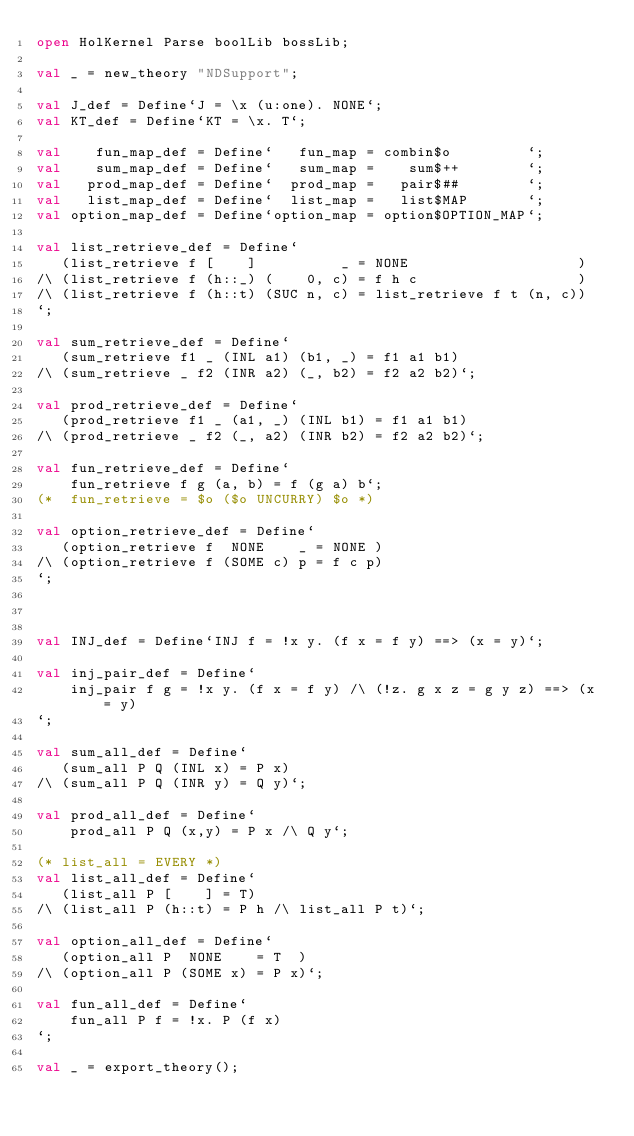Convert code to text. <code><loc_0><loc_0><loc_500><loc_500><_SML_>open HolKernel Parse boolLib bossLib;

val _ = new_theory "NDSupport";

val J_def = Define`J = \x (u:one). NONE`;
val KT_def = Define`KT = \x. T`;

val    fun_map_def = Define`   fun_map = combin$o         `;
val    sum_map_def = Define`   sum_map =    sum$++        `;
val   prod_map_def = Define`  prod_map =   pair$##        `;
val   list_map_def = Define`  list_map =   list$MAP       `;
val option_map_def = Define`option_map = option$OPTION_MAP`;

val list_retrieve_def = Define`
   (list_retrieve f [    ]          _ = NONE                    )
/\ (list_retrieve f (h::_) (    0, c) = f h c                   )
/\ (list_retrieve f (h::t) (SUC n, c) = list_retrieve f t (n, c))
`;

val sum_retrieve_def = Define`
   (sum_retrieve f1 _ (INL a1) (b1, _) = f1 a1 b1)
/\ (sum_retrieve _ f2 (INR a2) (_, b2) = f2 a2 b2)`;

val prod_retrieve_def = Define`
   (prod_retrieve f1 _ (a1, _) (INL b1) = f1 a1 b1)
/\ (prod_retrieve _ f2 (_, a2) (INR b2) = f2 a2 b2)`;

val fun_retrieve_def = Define`
    fun_retrieve f g (a, b) = f (g a) b`;
(*  fun_retrieve = $o ($o UNCURRY) $o *)

val option_retrieve_def = Define`
   (option_retrieve f  NONE    _ = NONE )
/\ (option_retrieve f (SOME c) p = f c p)
`;



val INJ_def = Define`INJ f = !x y. (f x = f y) ==> (x = y)`;

val inj_pair_def = Define`
    inj_pair f g = !x y. (f x = f y) /\ (!z. g x z = g y z) ==> (x = y)
`;

val sum_all_def = Define`
   (sum_all P Q (INL x) = P x)
/\ (sum_all P Q (INR y) = Q y)`;

val prod_all_def = Define`
    prod_all P Q (x,y) = P x /\ Q y`;

(* list_all = EVERY *)
val list_all_def = Define`
   (list_all P [    ] = T)
/\ (list_all P (h::t) = P h /\ list_all P t)`;

val option_all_def = Define`
   (option_all P  NONE    = T  )
/\ (option_all P (SOME x) = P x)`;

val fun_all_def = Define`
    fun_all P f = !x. P (f x)
`;

val _ = export_theory();

</code> 